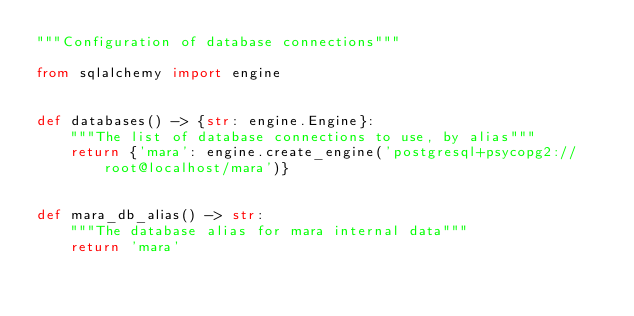Convert code to text. <code><loc_0><loc_0><loc_500><loc_500><_Python_>"""Configuration of database connections"""

from sqlalchemy import engine


def databases() -> {str: engine.Engine}:
    """The list of database connections to use, by alias"""
    return {'mara': engine.create_engine('postgresql+psycopg2://root@localhost/mara')}


def mara_db_alias() -> str:
    """The database alias for mara internal data"""
    return 'mara'


</code> 